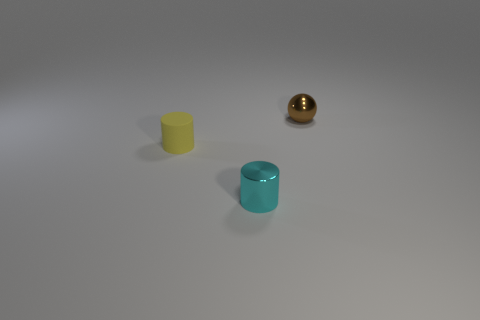What atmosphere or mood does the lighting of the image convey? The image has soft and diffused lighting which casts gentle shadows and gives the scene a calm and minimalist atmosphere. The neutral background does not distract from the objects, contributing to a tranquil and clean mood. 